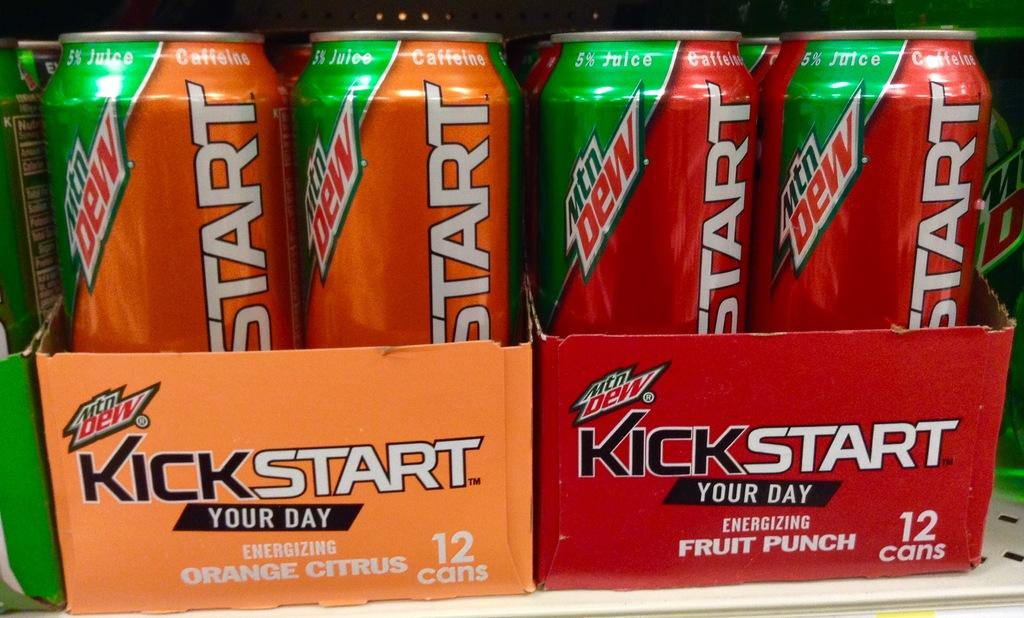<image>
Share a concise interpretation of the image provided. Two twelve packs of Kickstart in orange citrus and fruit punch. 